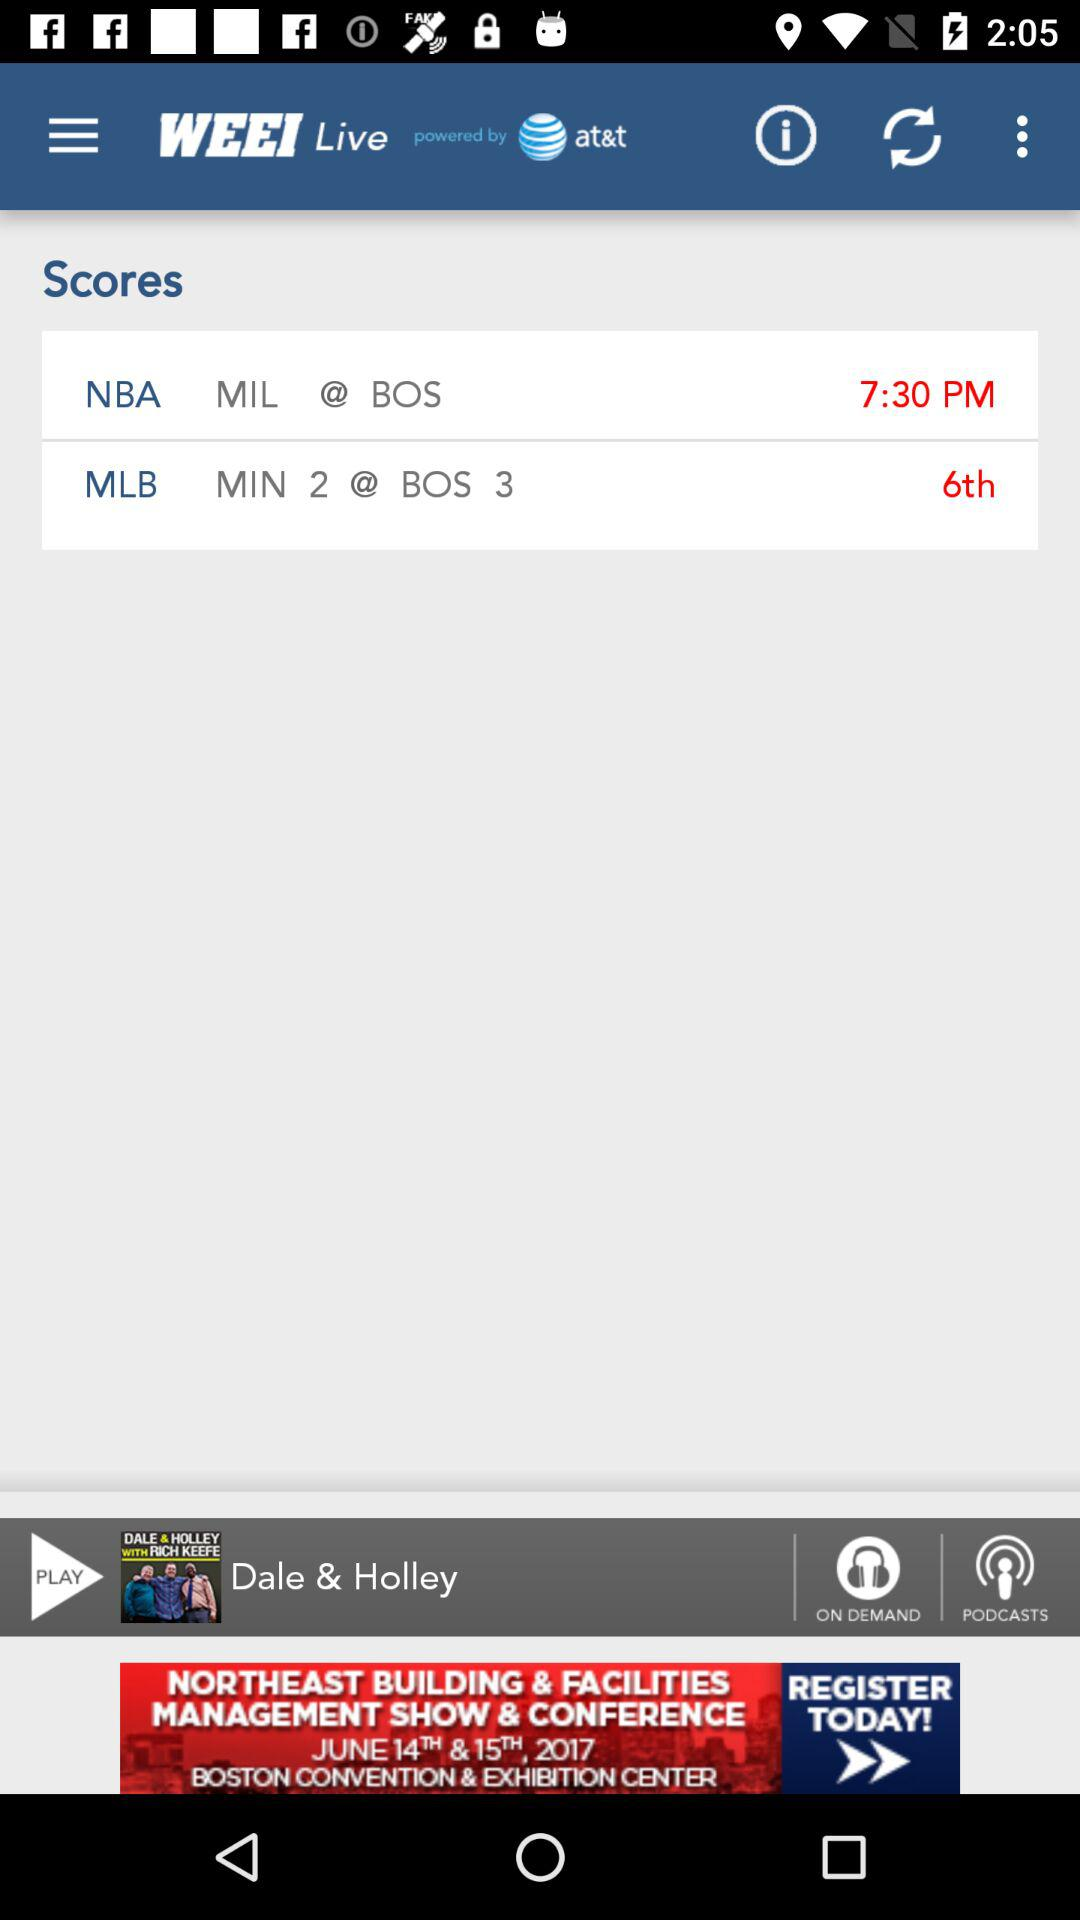How long is the podcast "Dale & Holley"?
When the provided information is insufficient, respond with <no answer>. <no answer> 